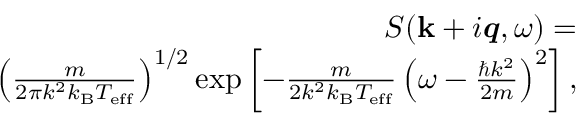<formula> <loc_0><loc_0><loc_500><loc_500>\begin{array} { r } { S ( { k } + i \mathbf i t { q } , \omega ) = } \\ { \left ( \frac { m } { 2 \pi k ^ { 2 } k _ { B } T _ { e f f } } \right ) ^ { 1 / 2 } \exp \left [ - \frac { m } { 2 k ^ { 2 } k _ { B } T _ { e f f } } \left ( \omega - \frac { \hbar { k } ^ { 2 } } { 2 m } \right ) ^ { 2 } \right ] , } \end{array}</formula> 